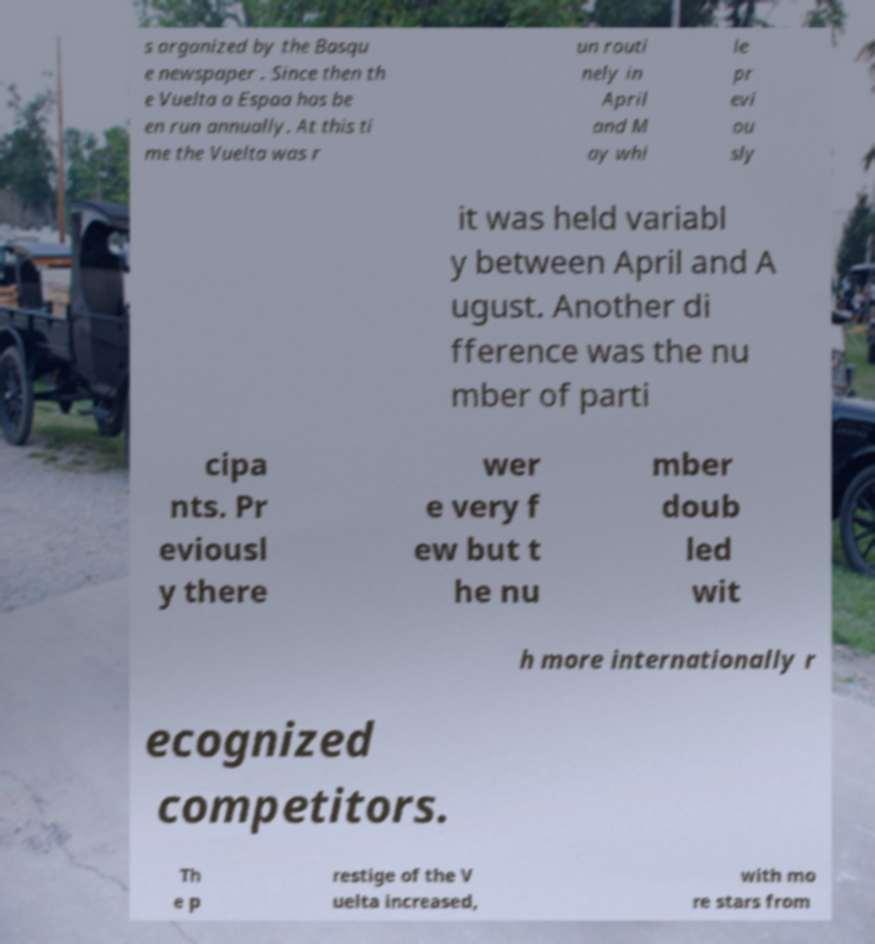For documentation purposes, I need the text within this image transcribed. Could you provide that? s organized by the Basqu e newspaper . Since then th e Vuelta a Espaa has be en run annually. At this ti me the Vuelta was r un routi nely in April and M ay whi le pr evi ou sly it was held variabl y between April and A ugust. Another di fference was the nu mber of parti cipa nts. Pr eviousl y there wer e very f ew but t he nu mber doub led wit h more internationally r ecognized competitors. Th e p restige of the V uelta increased, with mo re stars from 